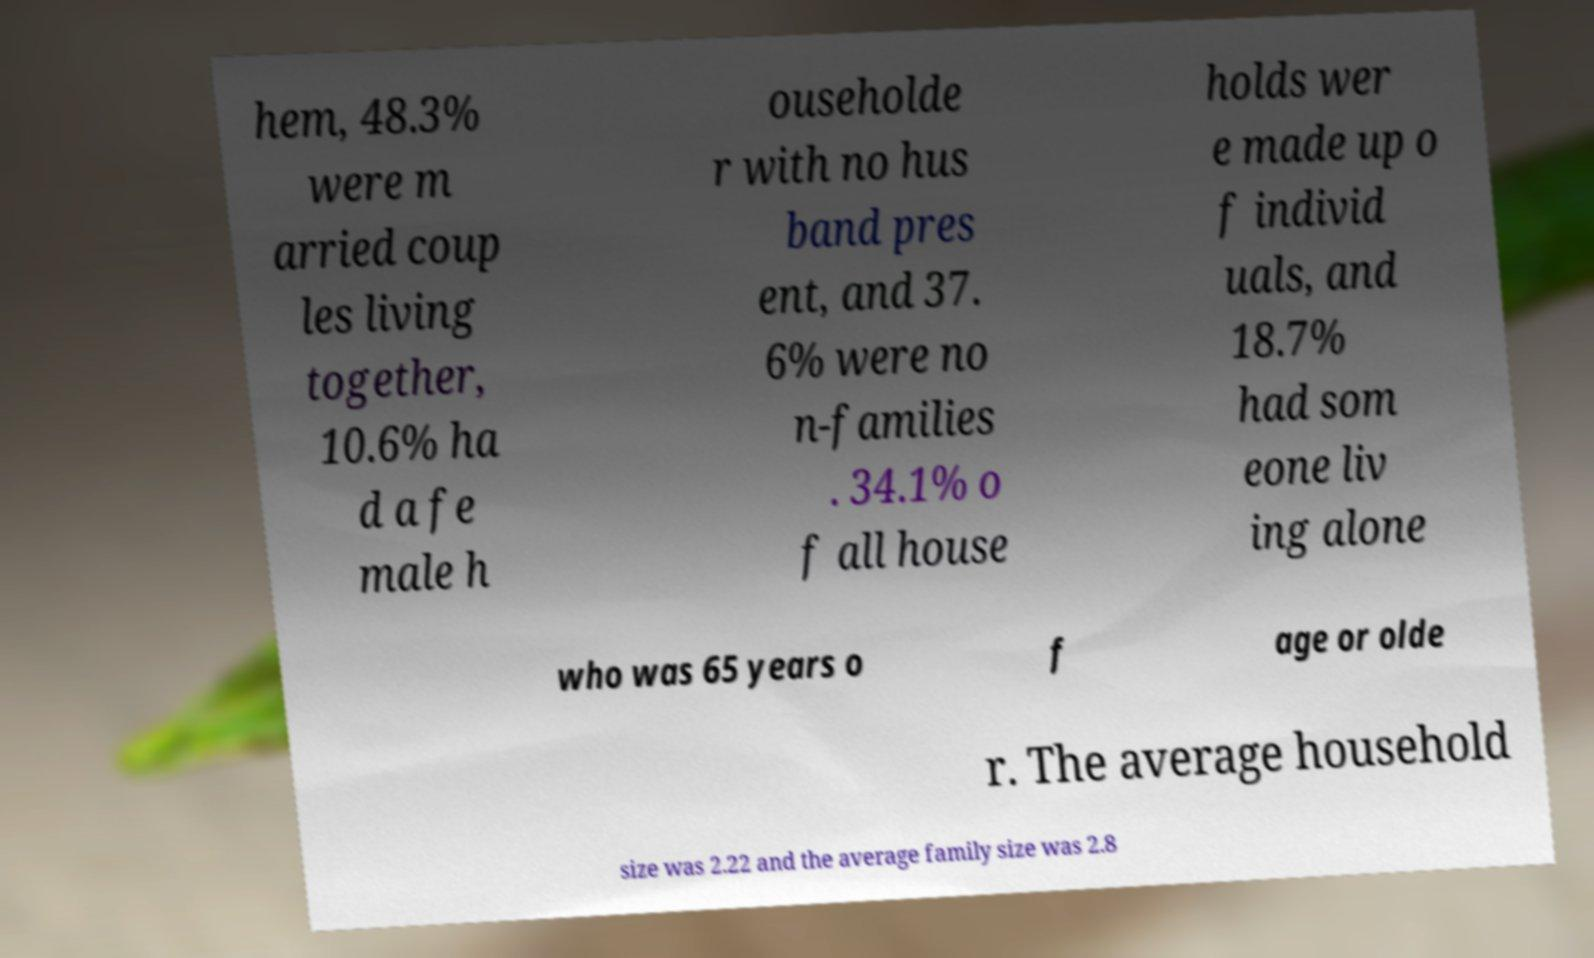There's text embedded in this image that I need extracted. Can you transcribe it verbatim? hem, 48.3% were m arried coup les living together, 10.6% ha d a fe male h ouseholde r with no hus band pres ent, and 37. 6% were no n-families . 34.1% o f all house holds wer e made up o f individ uals, and 18.7% had som eone liv ing alone who was 65 years o f age or olde r. The average household size was 2.22 and the average family size was 2.8 